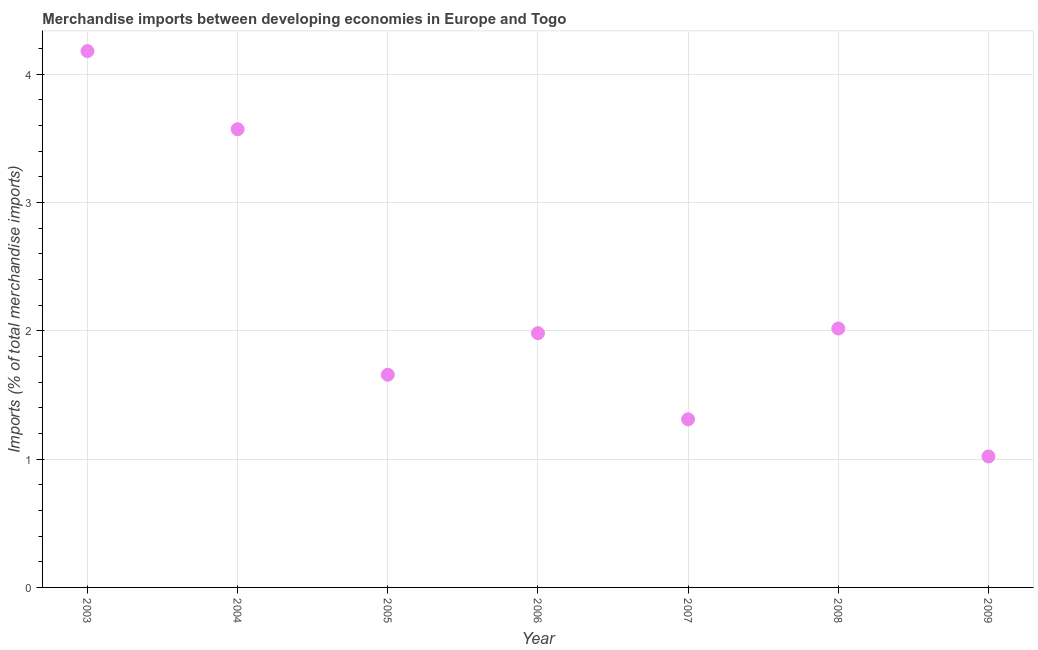What is the merchandise imports in 2009?
Your answer should be very brief. 1.02. Across all years, what is the maximum merchandise imports?
Ensure brevity in your answer.  4.18. Across all years, what is the minimum merchandise imports?
Offer a terse response. 1.02. In which year was the merchandise imports maximum?
Offer a very short reply. 2003. In which year was the merchandise imports minimum?
Provide a short and direct response. 2009. What is the sum of the merchandise imports?
Your answer should be compact. 15.73. What is the difference between the merchandise imports in 2003 and 2007?
Offer a terse response. 2.87. What is the average merchandise imports per year?
Offer a very short reply. 2.25. What is the median merchandise imports?
Provide a succinct answer. 1.98. Do a majority of the years between 2007 and 2008 (inclusive) have merchandise imports greater than 1.8 %?
Give a very brief answer. No. What is the ratio of the merchandise imports in 2007 to that in 2008?
Your response must be concise. 0.65. Is the difference between the merchandise imports in 2004 and 2009 greater than the difference between any two years?
Offer a very short reply. No. What is the difference between the highest and the second highest merchandise imports?
Your answer should be very brief. 0.61. What is the difference between the highest and the lowest merchandise imports?
Your answer should be compact. 3.16. What is the difference between two consecutive major ticks on the Y-axis?
Make the answer very short. 1. Does the graph contain any zero values?
Your response must be concise. No. What is the title of the graph?
Offer a terse response. Merchandise imports between developing economies in Europe and Togo. What is the label or title of the X-axis?
Offer a very short reply. Year. What is the label or title of the Y-axis?
Provide a succinct answer. Imports (% of total merchandise imports). What is the Imports (% of total merchandise imports) in 2003?
Offer a terse response. 4.18. What is the Imports (% of total merchandise imports) in 2004?
Ensure brevity in your answer.  3.57. What is the Imports (% of total merchandise imports) in 2005?
Give a very brief answer. 1.66. What is the Imports (% of total merchandise imports) in 2006?
Provide a succinct answer. 1.98. What is the Imports (% of total merchandise imports) in 2007?
Keep it short and to the point. 1.31. What is the Imports (% of total merchandise imports) in 2008?
Offer a very short reply. 2.02. What is the Imports (% of total merchandise imports) in 2009?
Provide a succinct answer. 1.02. What is the difference between the Imports (% of total merchandise imports) in 2003 and 2004?
Offer a very short reply. 0.61. What is the difference between the Imports (% of total merchandise imports) in 2003 and 2005?
Your answer should be compact. 2.52. What is the difference between the Imports (% of total merchandise imports) in 2003 and 2006?
Ensure brevity in your answer.  2.2. What is the difference between the Imports (% of total merchandise imports) in 2003 and 2007?
Your response must be concise. 2.87. What is the difference between the Imports (% of total merchandise imports) in 2003 and 2008?
Your answer should be compact. 2.16. What is the difference between the Imports (% of total merchandise imports) in 2003 and 2009?
Give a very brief answer. 3.16. What is the difference between the Imports (% of total merchandise imports) in 2004 and 2005?
Offer a terse response. 1.91. What is the difference between the Imports (% of total merchandise imports) in 2004 and 2006?
Provide a succinct answer. 1.59. What is the difference between the Imports (% of total merchandise imports) in 2004 and 2007?
Provide a succinct answer. 2.26. What is the difference between the Imports (% of total merchandise imports) in 2004 and 2008?
Give a very brief answer. 1.55. What is the difference between the Imports (% of total merchandise imports) in 2004 and 2009?
Your response must be concise. 2.55. What is the difference between the Imports (% of total merchandise imports) in 2005 and 2006?
Give a very brief answer. -0.32. What is the difference between the Imports (% of total merchandise imports) in 2005 and 2007?
Offer a very short reply. 0.35. What is the difference between the Imports (% of total merchandise imports) in 2005 and 2008?
Give a very brief answer. -0.36. What is the difference between the Imports (% of total merchandise imports) in 2005 and 2009?
Offer a very short reply. 0.64. What is the difference between the Imports (% of total merchandise imports) in 2006 and 2007?
Your response must be concise. 0.67. What is the difference between the Imports (% of total merchandise imports) in 2006 and 2008?
Provide a succinct answer. -0.04. What is the difference between the Imports (% of total merchandise imports) in 2006 and 2009?
Your answer should be compact. 0.96. What is the difference between the Imports (% of total merchandise imports) in 2007 and 2008?
Provide a short and direct response. -0.71. What is the difference between the Imports (% of total merchandise imports) in 2007 and 2009?
Offer a terse response. 0.29. What is the ratio of the Imports (% of total merchandise imports) in 2003 to that in 2004?
Keep it short and to the point. 1.17. What is the ratio of the Imports (% of total merchandise imports) in 2003 to that in 2005?
Keep it short and to the point. 2.52. What is the ratio of the Imports (% of total merchandise imports) in 2003 to that in 2006?
Offer a very short reply. 2.11. What is the ratio of the Imports (% of total merchandise imports) in 2003 to that in 2007?
Keep it short and to the point. 3.19. What is the ratio of the Imports (% of total merchandise imports) in 2003 to that in 2008?
Make the answer very short. 2.07. What is the ratio of the Imports (% of total merchandise imports) in 2003 to that in 2009?
Your answer should be compact. 4.09. What is the ratio of the Imports (% of total merchandise imports) in 2004 to that in 2005?
Your answer should be compact. 2.15. What is the ratio of the Imports (% of total merchandise imports) in 2004 to that in 2006?
Give a very brief answer. 1.8. What is the ratio of the Imports (% of total merchandise imports) in 2004 to that in 2007?
Provide a succinct answer. 2.73. What is the ratio of the Imports (% of total merchandise imports) in 2004 to that in 2008?
Your answer should be very brief. 1.77. What is the ratio of the Imports (% of total merchandise imports) in 2004 to that in 2009?
Your answer should be compact. 3.5. What is the ratio of the Imports (% of total merchandise imports) in 2005 to that in 2006?
Provide a short and direct response. 0.84. What is the ratio of the Imports (% of total merchandise imports) in 2005 to that in 2007?
Offer a terse response. 1.26. What is the ratio of the Imports (% of total merchandise imports) in 2005 to that in 2008?
Offer a terse response. 0.82. What is the ratio of the Imports (% of total merchandise imports) in 2005 to that in 2009?
Provide a short and direct response. 1.62. What is the ratio of the Imports (% of total merchandise imports) in 2006 to that in 2007?
Give a very brief answer. 1.51. What is the ratio of the Imports (% of total merchandise imports) in 2006 to that in 2008?
Your response must be concise. 0.98. What is the ratio of the Imports (% of total merchandise imports) in 2006 to that in 2009?
Keep it short and to the point. 1.94. What is the ratio of the Imports (% of total merchandise imports) in 2007 to that in 2008?
Make the answer very short. 0.65. What is the ratio of the Imports (% of total merchandise imports) in 2007 to that in 2009?
Your response must be concise. 1.28. What is the ratio of the Imports (% of total merchandise imports) in 2008 to that in 2009?
Provide a succinct answer. 1.98. 